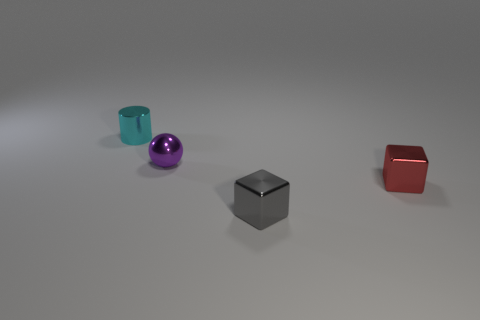There is a small sphere that is made of the same material as the tiny cylinder; what color is it? The small sphere in the image reflects a shiny, metallic purple hue, indicative of the material's glossy finish, which it shares with the tiny cylinder to its left. 